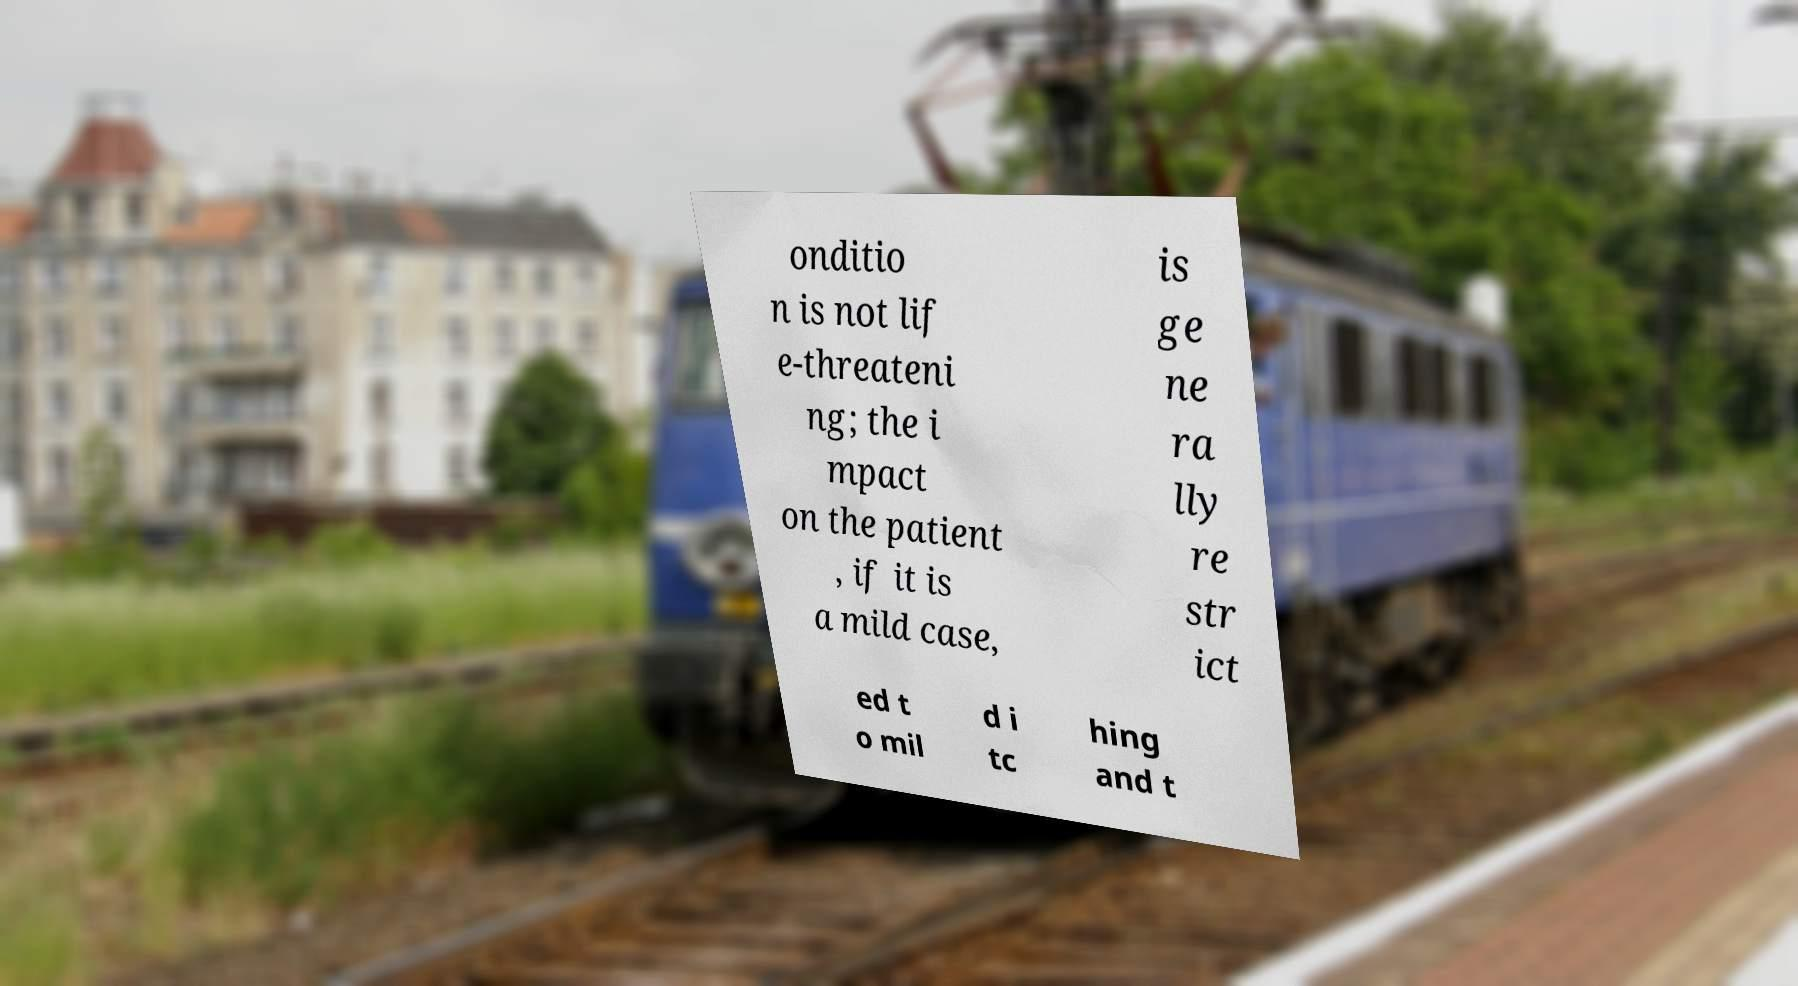Please read and relay the text visible in this image. What does it say? onditio n is not lif e-threateni ng; the i mpact on the patient , if it is a mild case, is ge ne ra lly re str ict ed t o mil d i tc hing and t 